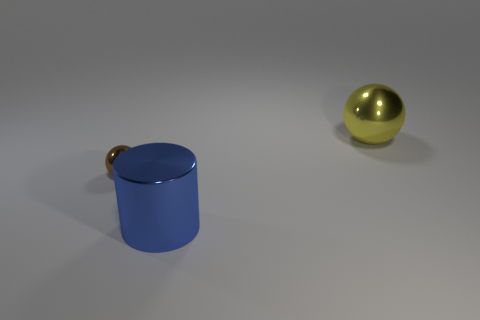Add 2 tiny brown objects. How many objects exist? 5 Subtract all balls. How many objects are left? 1 Subtract 0 purple cylinders. How many objects are left? 3 Subtract all big red things. Subtract all large yellow shiny things. How many objects are left? 2 Add 3 brown shiny spheres. How many brown shiny spheres are left? 4 Add 3 large green rubber objects. How many large green rubber objects exist? 3 